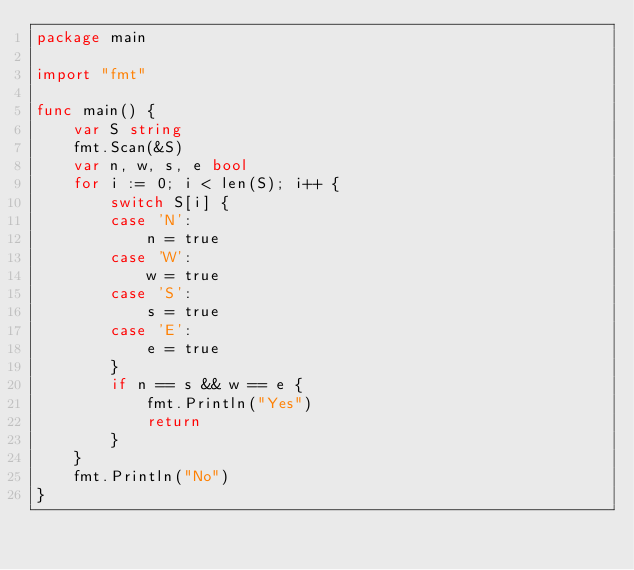<code> <loc_0><loc_0><loc_500><loc_500><_Go_>package main

import "fmt"

func main() {
	var S string
	fmt.Scan(&S)
	var n, w, s, e bool
	for i := 0; i < len(S); i++ {
		switch S[i] {
		case 'N':
			n = true
		case 'W':
			w = true
		case 'S':
			s = true
		case 'E':
			e = true
		}
		if n == s && w == e {
			fmt.Println("Yes")
			return
		}
	}
	fmt.Println("No")
}
</code> 